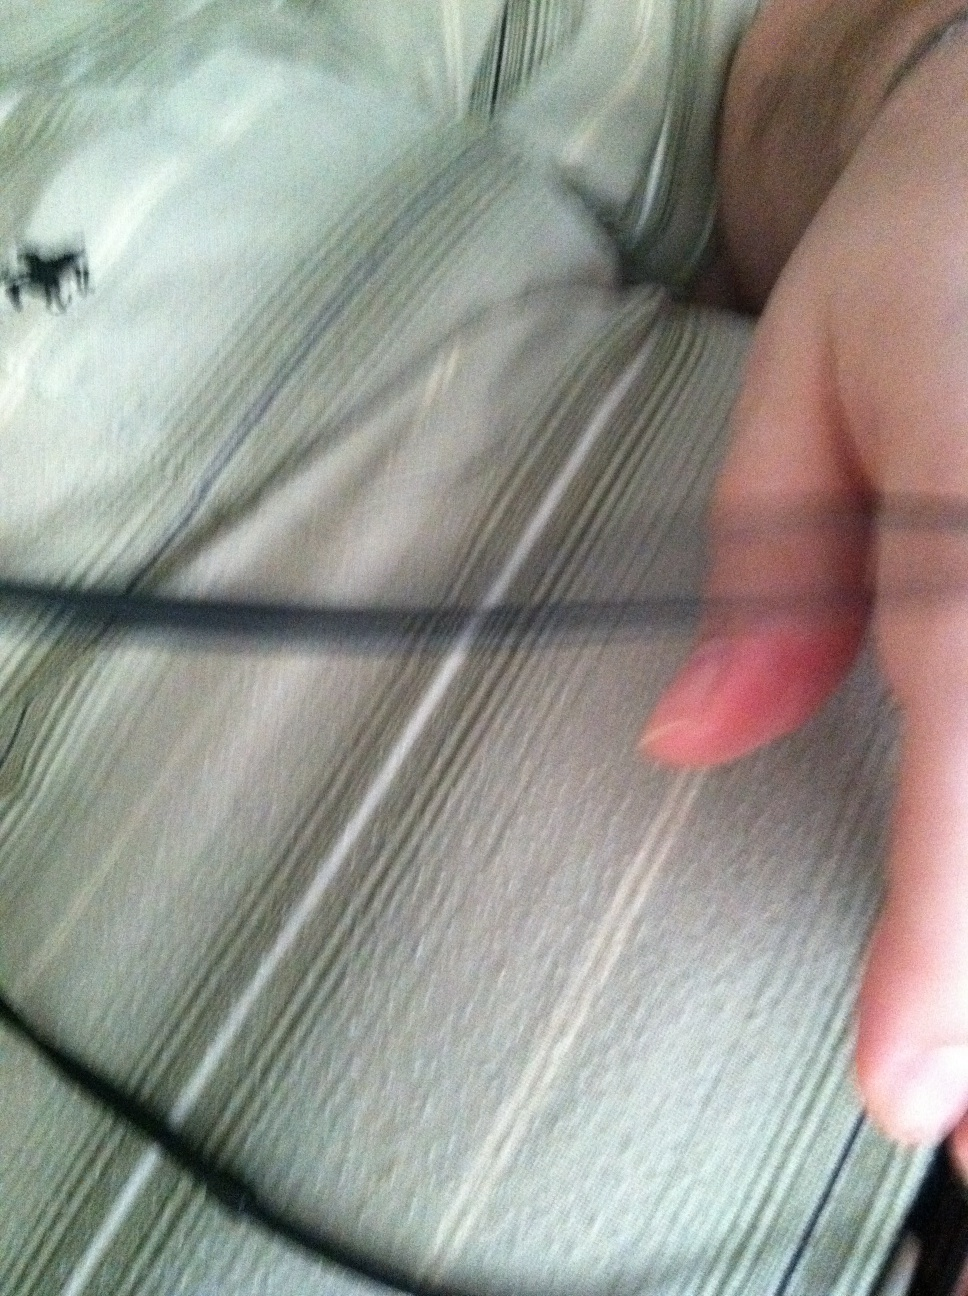If my shirt could talk, what do you think it would say? If your shirt could talk, it might say something like, 'I'm effortlessly stylish and perfect for any casual occasion. My stripes give me a flair of understated elegance, and I keep you comfortable all day long!' 